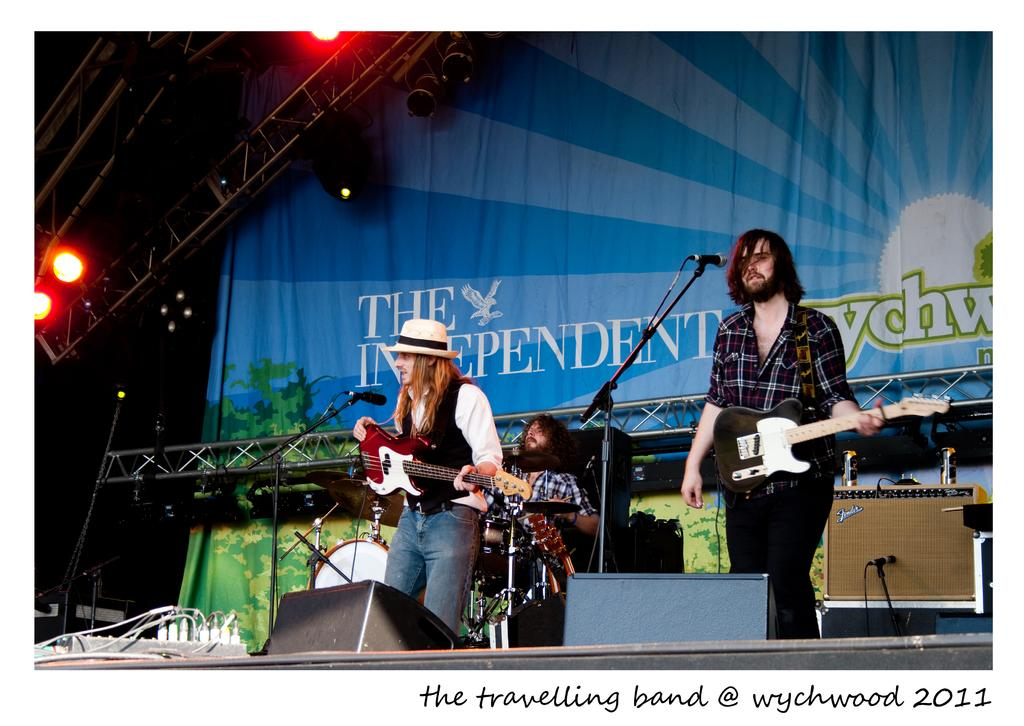How many people are in the image? There are three persons in the image. What are the people doing in the image? One person is playing the drum set, and two persons are playing the guitar. What is used for amplifying the sound of the vocals in the image? There is a microphone in the image. What type of lighting is present in the image? There are disco lights in the image. What type of pleasure can be seen on the mouth of the person playing the guitar? There is no indication of pleasure on the mouth of the person playing the guitar in the image. 